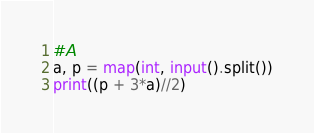<code> <loc_0><loc_0><loc_500><loc_500><_Python_>#A
a, p = map(int, input().split())
print((p + 3*a)//2)</code> 